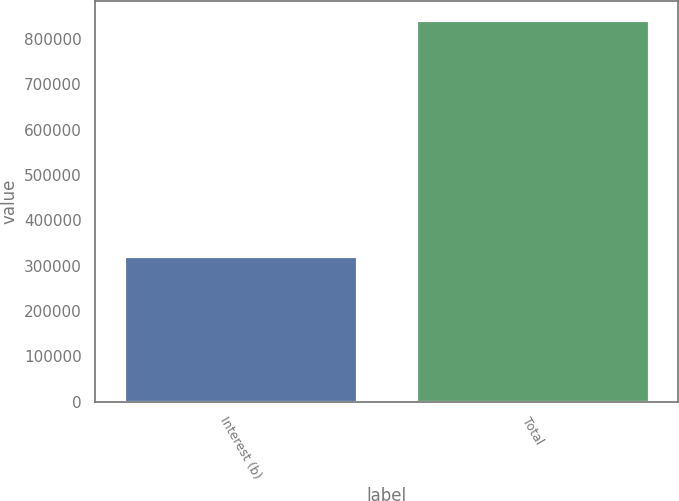Convert chart to OTSL. <chart><loc_0><loc_0><loc_500><loc_500><bar_chart><fcel>Interest (b)<fcel>Total<nl><fcel>321272<fcel>842203<nl></chart> 